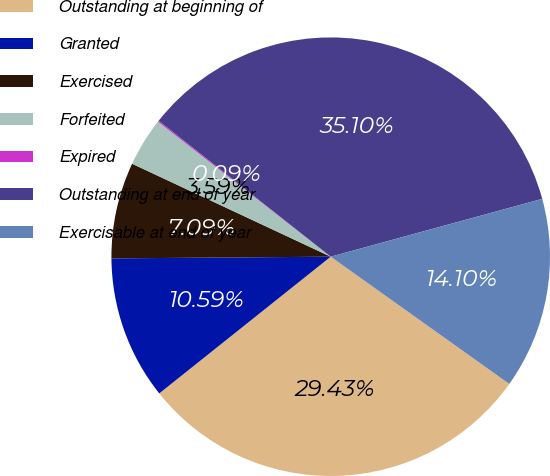Convert chart to OTSL. <chart><loc_0><loc_0><loc_500><loc_500><pie_chart><fcel>Outstanding at beginning of<fcel>Granted<fcel>Exercised<fcel>Forfeited<fcel>Expired<fcel>Outstanding at end of year<fcel>Exercisable at end of year<nl><fcel>29.43%<fcel>10.59%<fcel>7.09%<fcel>3.59%<fcel>0.09%<fcel>35.1%<fcel>14.1%<nl></chart> 